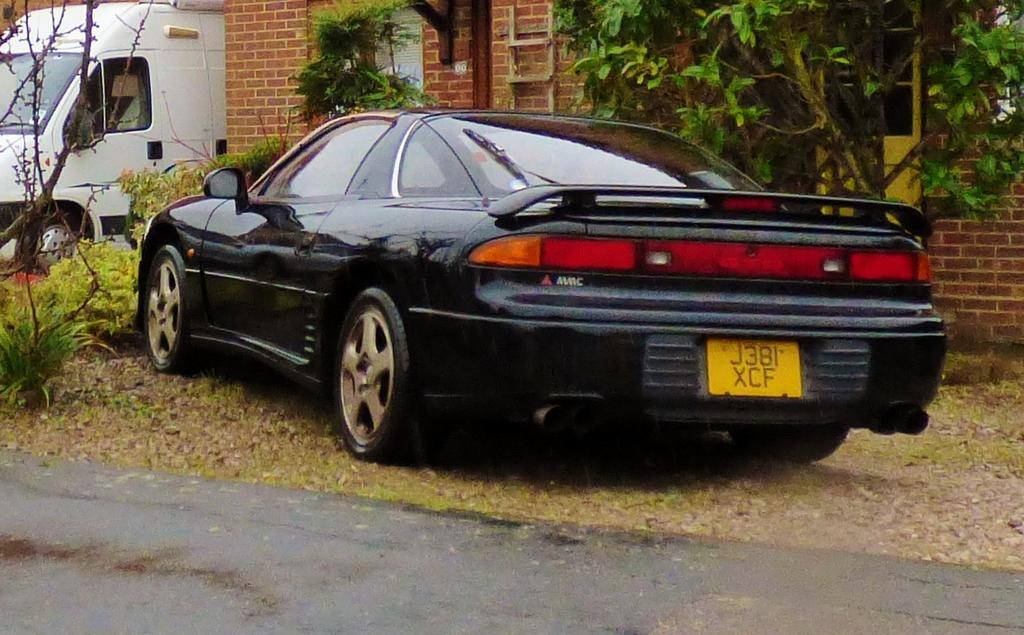What color is the car in the image? The car in the image is black. What color is the truck in the image? The truck in the image is white. What type of structure can be seen in the image? There is a building in the image. What type of vegetation is present in the image? There are trees and plants in the image. What type of crayon is being used to draw on the building in the image? There is no crayon or drawing activity present in the image. What word is written on the side of the truck in the image? There is no word visible on the truck in the image. 